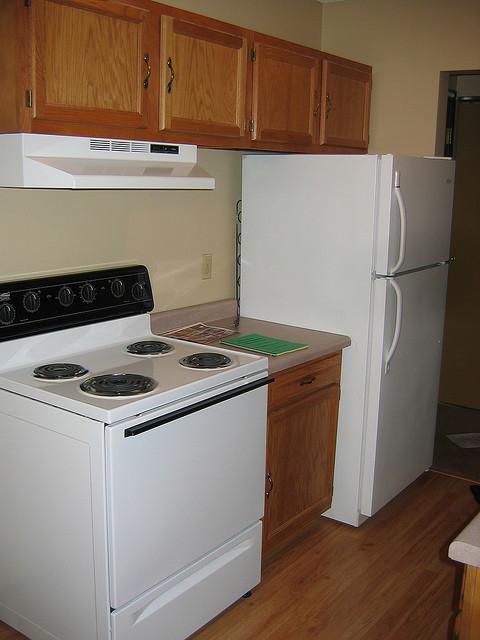Is there a lot of counter room?
Answer briefly. No. What color are the appliances?
Concise answer only. White. How many burners does the stove have?
Concise answer only. 4. Is there a hood over the stove?
Be succinct. Yes. 